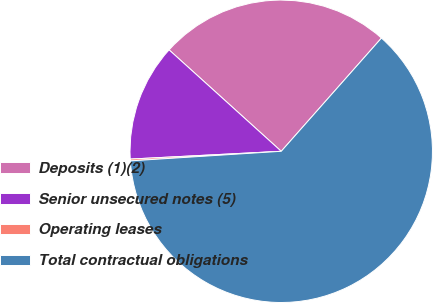Convert chart to OTSL. <chart><loc_0><loc_0><loc_500><loc_500><pie_chart><fcel>Deposits (1)(2)<fcel>Senior unsecured notes (5)<fcel>Operating leases<fcel>Total contractual obligations<nl><fcel>24.83%<fcel>12.52%<fcel>0.19%<fcel>62.46%<nl></chart> 